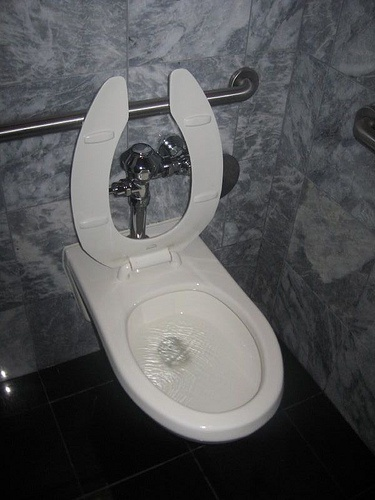Describe the objects in this image and their specific colors. I can see a toilet in black, darkgray, gray, and lightgray tones in this image. 